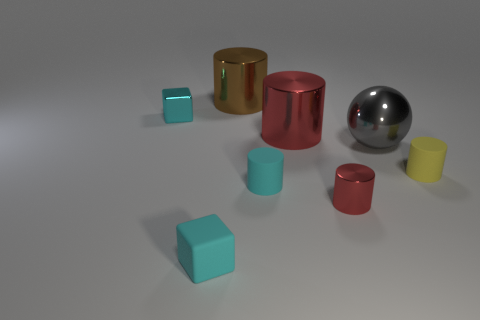Subtract all red cylinders. How many were subtracted if there are1red cylinders left? 1 Subtract all blue blocks. How many red cylinders are left? 2 Subtract 1 cylinders. How many cylinders are left? 4 Subtract all small cyan matte cylinders. How many cylinders are left? 4 Subtract all brown cylinders. How many cylinders are left? 4 Add 1 tiny yellow cylinders. How many objects exist? 9 Subtract all gray cylinders. Subtract all cyan cubes. How many cylinders are left? 5 Subtract all spheres. How many objects are left? 7 Add 7 small metallic spheres. How many small metallic spheres exist? 7 Subtract 0 green cylinders. How many objects are left? 8 